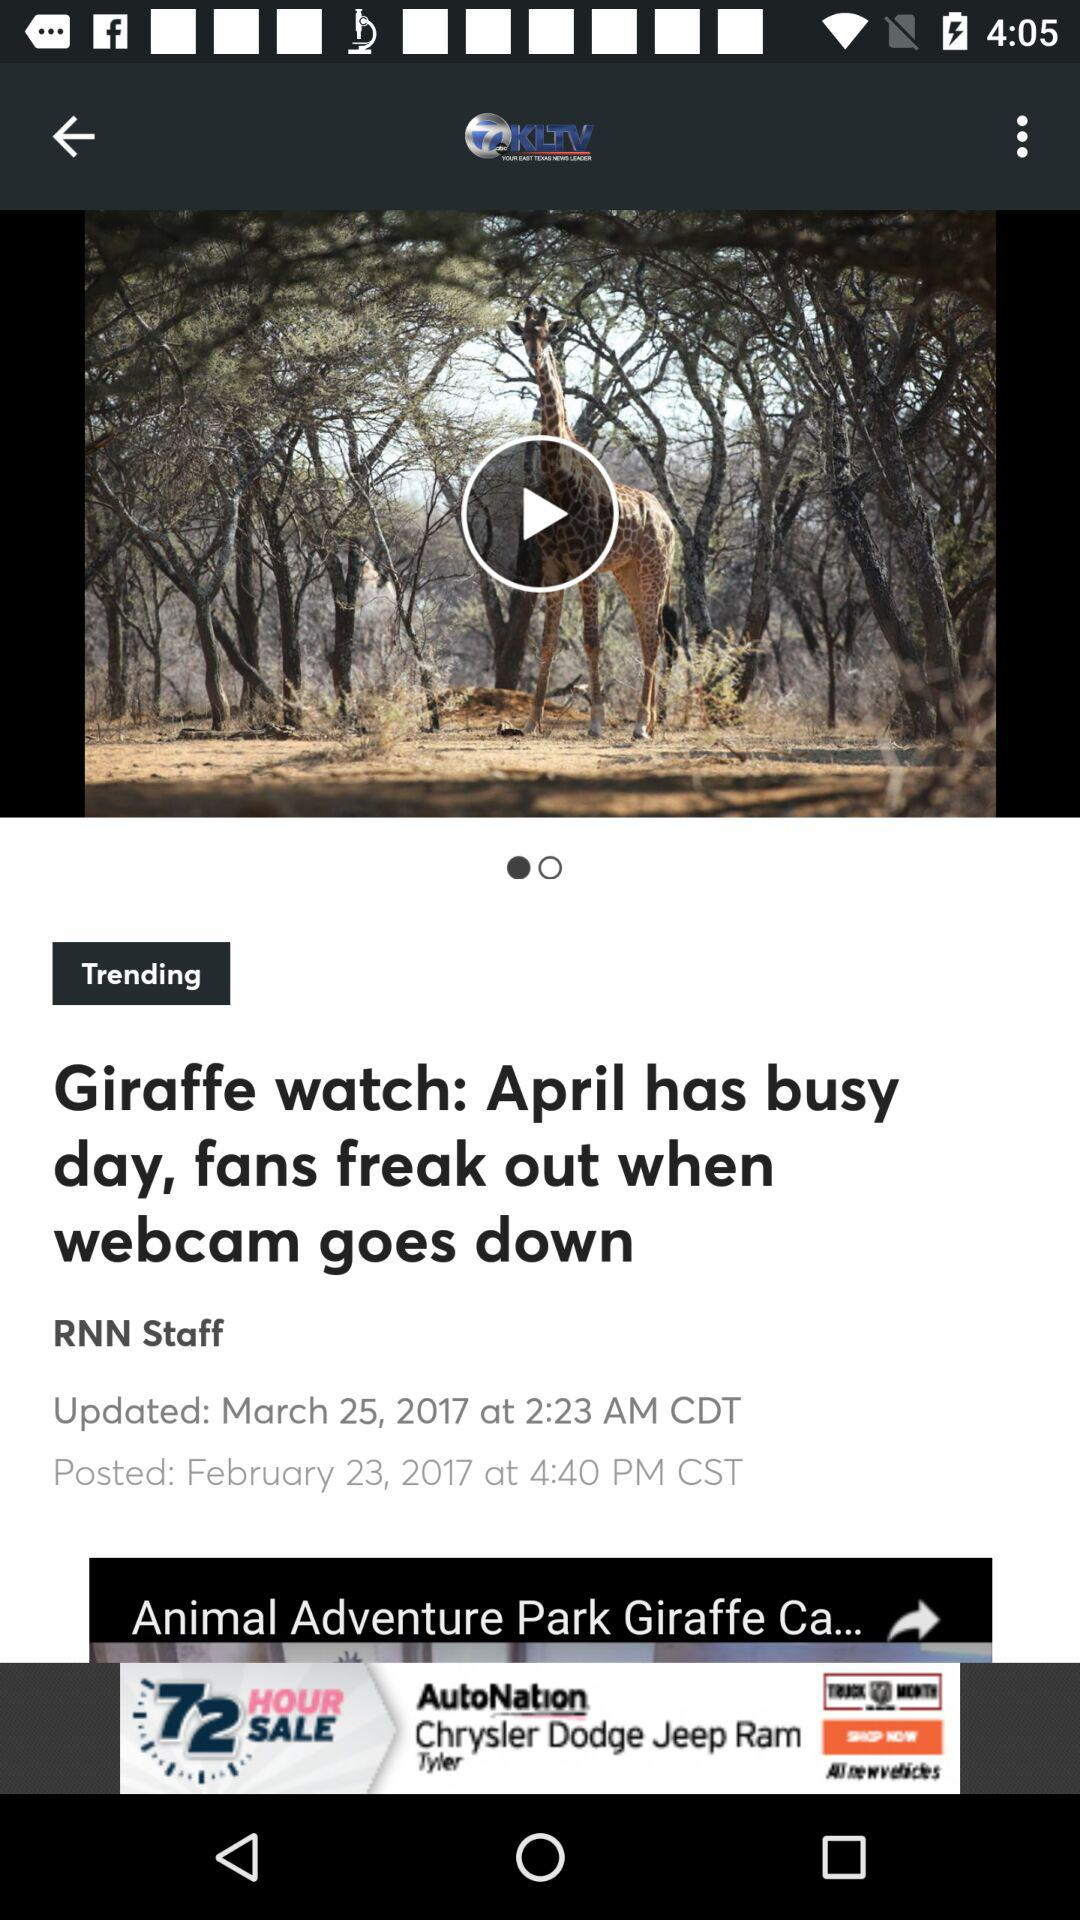When was the news posted? The news was posted on February 23, 2017 at 4:40 PM CST. 